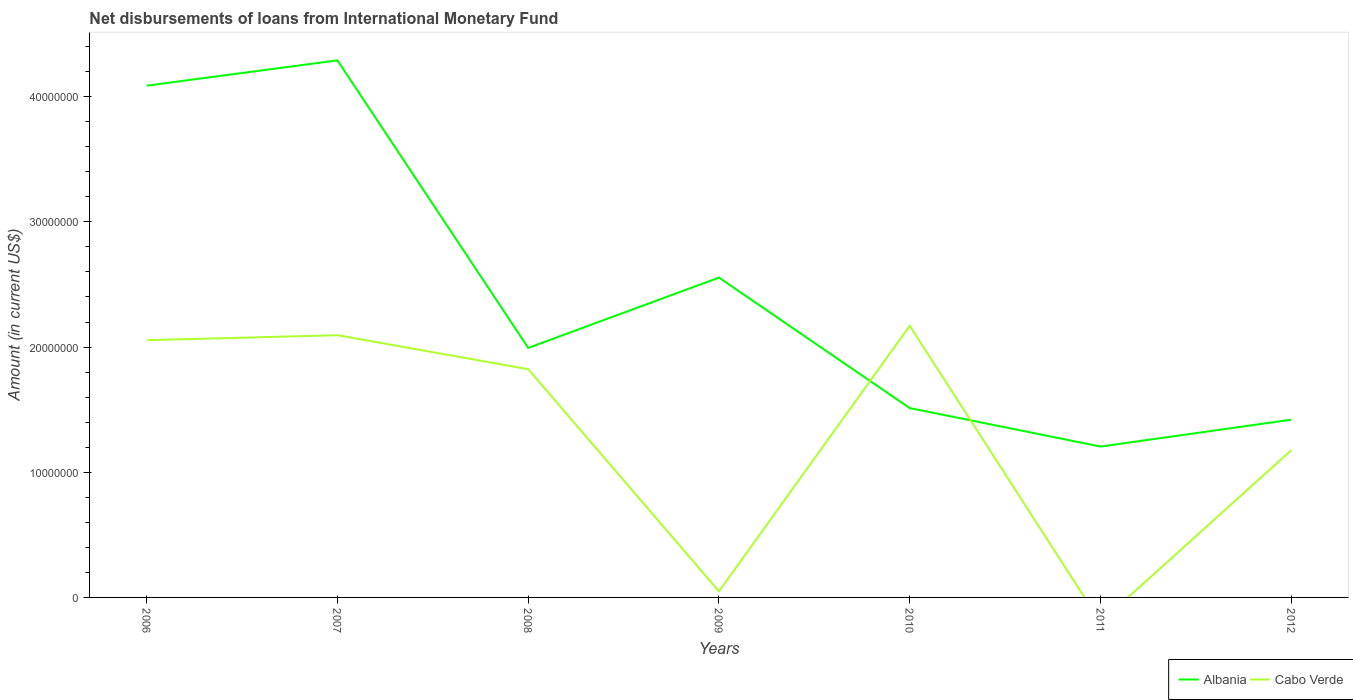How many different coloured lines are there?
Your answer should be very brief. 2. Is the number of lines equal to the number of legend labels?
Your answer should be very brief. No. Across all years, what is the maximum amount of loans disbursed in Albania?
Make the answer very short. 1.21e+07. What is the total amount of loans disbursed in Albania in the graph?
Your answer should be very brief. 1.35e+07. What is the difference between the highest and the second highest amount of loans disbursed in Albania?
Your answer should be very brief. 3.08e+07. What is the difference between the highest and the lowest amount of loans disbursed in Albania?
Your answer should be compact. 3. Is the amount of loans disbursed in Albania strictly greater than the amount of loans disbursed in Cabo Verde over the years?
Provide a succinct answer. No. Does the graph contain any zero values?
Your answer should be compact. Yes. How many legend labels are there?
Keep it short and to the point. 2. How are the legend labels stacked?
Provide a short and direct response. Horizontal. What is the title of the graph?
Provide a succinct answer. Net disbursements of loans from International Monetary Fund. What is the label or title of the X-axis?
Your response must be concise. Years. What is the label or title of the Y-axis?
Ensure brevity in your answer.  Amount (in current US$). What is the Amount (in current US$) in Albania in 2006?
Give a very brief answer. 4.09e+07. What is the Amount (in current US$) in Cabo Verde in 2006?
Give a very brief answer. 2.05e+07. What is the Amount (in current US$) in Albania in 2007?
Your answer should be compact. 4.29e+07. What is the Amount (in current US$) of Cabo Verde in 2007?
Your answer should be compact. 2.09e+07. What is the Amount (in current US$) in Albania in 2008?
Your response must be concise. 1.99e+07. What is the Amount (in current US$) of Cabo Verde in 2008?
Offer a terse response. 1.82e+07. What is the Amount (in current US$) in Albania in 2009?
Ensure brevity in your answer.  2.55e+07. What is the Amount (in current US$) in Cabo Verde in 2009?
Ensure brevity in your answer.  4.88e+05. What is the Amount (in current US$) in Albania in 2010?
Provide a short and direct response. 1.51e+07. What is the Amount (in current US$) of Cabo Verde in 2010?
Your answer should be very brief. 2.17e+07. What is the Amount (in current US$) of Albania in 2011?
Your answer should be compact. 1.21e+07. What is the Amount (in current US$) of Albania in 2012?
Provide a succinct answer. 1.42e+07. What is the Amount (in current US$) in Cabo Verde in 2012?
Provide a short and direct response. 1.18e+07. Across all years, what is the maximum Amount (in current US$) of Albania?
Provide a succinct answer. 4.29e+07. Across all years, what is the maximum Amount (in current US$) of Cabo Verde?
Offer a terse response. 2.17e+07. Across all years, what is the minimum Amount (in current US$) in Albania?
Keep it short and to the point. 1.21e+07. What is the total Amount (in current US$) in Albania in the graph?
Offer a terse response. 1.71e+08. What is the total Amount (in current US$) of Cabo Verde in the graph?
Keep it short and to the point. 9.37e+07. What is the difference between the Amount (in current US$) in Albania in 2006 and that in 2007?
Offer a terse response. -2.02e+06. What is the difference between the Amount (in current US$) of Cabo Verde in 2006 and that in 2007?
Make the answer very short. -3.97e+05. What is the difference between the Amount (in current US$) in Albania in 2006 and that in 2008?
Provide a succinct answer. 2.09e+07. What is the difference between the Amount (in current US$) in Cabo Verde in 2006 and that in 2008?
Provide a short and direct response. 2.32e+06. What is the difference between the Amount (in current US$) in Albania in 2006 and that in 2009?
Offer a very short reply. 1.53e+07. What is the difference between the Amount (in current US$) of Cabo Verde in 2006 and that in 2009?
Your answer should be very brief. 2.01e+07. What is the difference between the Amount (in current US$) in Albania in 2006 and that in 2010?
Offer a very short reply. 2.58e+07. What is the difference between the Amount (in current US$) of Cabo Verde in 2006 and that in 2010?
Your answer should be compact. -1.15e+06. What is the difference between the Amount (in current US$) in Albania in 2006 and that in 2011?
Your answer should be compact. 2.88e+07. What is the difference between the Amount (in current US$) in Albania in 2006 and that in 2012?
Offer a very short reply. 2.67e+07. What is the difference between the Amount (in current US$) of Cabo Verde in 2006 and that in 2012?
Make the answer very short. 8.79e+06. What is the difference between the Amount (in current US$) of Albania in 2007 and that in 2008?
Provide a succinct answer. 2.30e+07. What is the difference between the Amount (in current US$) in Cabo Verde in 2007 and that in 2008?
Provide a short and direct response. 2.72e+06. What is the difference between the Amount (in current US$) of Albania in 2007 and that in 2009?
Offer a very short reply. 1.74e+07. What is the difference between the Amount (in current US$) of Cabo Verde in 2007 and that in 2009?
Provide a succinct answer. 2.05e+07. What is the difference between the Amount (in current US$) of Albania in 2007 and that in 2010?
Your answer should be compact. 2.78e+07. What is the difference between the Amount (in current US$) of Cabo Verde in 2007 and that in 2010?
Your answer should be very brief. -7.52e+05. What is the difference between the Amount (in current US$) of Albania in 2007 and that in 2011?
Provide a short and direct response. 3.08e+07. What is the difference between the Amount (in current US$) in Albania in 2007 and that in 2012?
Your response must be concise. 2.87e+07. What is the difference between the Amount (in current US$) of Cabo Verde in 2007 and that in 2012?
Keep it short and to the point. 9.18e+06. What is the difference between the Amount (in current US$) in Albania in 2008 and that in 2009?
Provide a short and direct response. -5.62e+06. What is the difference between the Amount (in current US$) of Cabo Verde in 2008 and that in 2009?
Your answer should be very brief. 1.77e+07. What is the difference between the Amount (in current US$) of Albania in 2008 and that in 2010?
Give a very brief answer. 4.81e+06. What is the difference between the Amount (in current US$) of Cabo Verde in 2008 and that in 2010?
Your answer should be compact. -3.47e+06. What is the difference between the Amount (in current US$) of Albania in 2008 and that in 2011?
Provide a succinct answer. 7.88e+06. What is the difference between the Amount (in current US$) in Albania in 2008 and that in 2012?
Your answer should be very brief. 5.73e+06. What is the difference between the Amount (in current US$) of Cabo Verde in 2008 and that in 2012?
Provide a short and direct response. 6.47e+06. What is the difference between the Amount (in current US$) in Albania in 2009 and that in 2010?
Ensure brevity in your answer.  1.04e+07. What is the difference between the Amount (in current US$) of Cabo Verde in 2009 and that in 2010?
Make the answer very short. -2.12e+07. What is the difference between the Amount (in current US$) of Albania in 2009 and that in 2011?
Make the answer very short. 1.35e+07. What is the difference between the Amount (in current US$) in Albania in 2009 and that in 2012?
Your response must be concise. 1.14e+07. What is the difference between the Amount (in current US$) in Cabo Verde in 2009 and that in 2012?
Offer a terse response. -1.13e+07. What is the difference between the Amount (in current US$) in Albania in 2010 and that in 2011?
Ensure brevity in your answer.  3.07e+06. What is the difference between the Amount (in current US$) in Albania in 2010 and that in 2012?
Provide a succinct answer. 9.26e+05. What is the difference between the Amount (in current US$) of Cabo Verde in 2010 and that in 2012?
Provide a succinct answer. 9.94e+06. What is the difference between the Amount (in current US$) of Albania in 2011 and that in 2012?
Ensure brevity in your answer.  -2.15e+06. What is the difference between the Amount (in current US$) of Albania in 2006 and the Amount (in current US$) of Cabo Verde in 2007?
Provide a succinct answer. 1.99e+07. What is the difference between the Amount (in current US$) in Albania in 2006 and the Amount (in current US$) in Cabo Verde in 2008?
Offer a terse response. 2.26e+07. What is the difference between the Amount (in current US$) in Albania in 2006 and the Amount (in current US$) in Cabo Verde in 2009?
Ensure brevity in your answer.  4.04e+07. What is the difference between the Amount (in current US$) of Albania in 2006 and the Amount (in current US$) of Cabo Verde in 2010?
Ensure brevity in your answer.  1.92e+07. What is the difference between the Amount (in current US$) of Albania in 2006 and the Amount (in current US$) of Cabo Verde in 2012?
Provide a short and direct response. 2.91e+07. What is the difference between the Amount (in current US$) in Albania in 2007 and the Amount (in current US$) in Cabo Verde in 2008?
Your answer should be very brief. 2.47e+07. What is the difference between the Amount (in current US$) of Albania in 2007 and the Amount (in current US$) of Cabo Verde in 2009?
Provide a short and direct response. 4.24e+07. What is the difference between the Amount (in current US$) in Albania in 2007 and the Amount (in current US$) in Cabo Verde in 2010?
Your response must be concise. 2.12e+07. What is the difference between the Amount (in current US$) of Albania in 2007 and the Amount (in current US$) of Cabo Verde in 2012?
Your answer should be very brief. 3.11e+07. What is the difference between the Amount (in current US$) in Albania in 2008 and the Amount (in current US$) in Cabo Verde in 2009?
Your answer should be very brief. 1.94e+07. What is the difference between the Amount (in current US$) of Albania in 2008 and the Amount (in current US$) of Cabo Verde in 2010?
Offer a terse response. -1.77e+06. What is the difference between the Amount (in current US$) of Albania in 2008 and the Amount (in current US$) of Cabo Verde in 2012?
Give a very brief answer. 8.17e+06. What is the difference between the Amount (in current US$) of Albania in 2009 and the Amount (in current US$) of Cabo Verde in 2010?
Give a very brief answer. 3.85e+06. What is the difference between the Amount (in current US$) of Albania in 2009 and the Amount (in current US$) of Cabo Verde in 2012?
Give a very brief answer. 1.38e+07. What is the difference between the Amount (in current US$) in Albania in 2010 and the Amount (in current US$) in Cabo Verde in 2012?
Provide a succinct answer. 3.36e+06. What is the average Amount (in current US$) of Albania per year?
Ensure brevity in your answer.  2.44e+07. What is the average Amount (in current US$) of Cabo Verde per year?
Give a very brief answer. 1.34e+07. In the year 2006, what is the difference between the Amount (in current US$) of Albania and Amount (in current US$) of Cabo Verde?
Provide a short and direct response. 2.03e+07. In the year 2007, what is the difference between the Amount (in current US$) in Albania and Amount (in current US$) in Cabo Verde?
Offer a very short reply. 2.20e+07. In the year 2008, what is the difference between the Amount (in current US$) in Albania and Amount (in current US$) in Cabo Verde?
Your answer should be compact. 1.70e+06. In the year 2009, what is the difference between the Amount (in current US$) of Albania and Amount (in current US$) of Cabo Verde?
Provide a succinct answer. 2.51e+07. In the year 2010, what is the difference between the Amount (in current US$) of Albania and Amount (in current US$) of Cabo Verde?
Give a very brief answer. -6.57e+06. In the year 2012, what is the difference between the Amount (in current US$) in Albania and Amount (in current US$) in Cabo Verde?
Provide a short and direct response. 2.44e+06. What is the ratio of the Amount (in current US$) in Albania in 2006 to that in 2007?
Give a very brief answer. 0.95. What is the ratio of the Amount (in current US$) of Cabo Verde in 2006 to that in 2007?
Make the answer very short. 0.98. What is the ratio of the Amount (in current US$) in Albania in 2006 to that in 2008?
Offer a very short reply. 2.05. What is the ratio of the Amount (in current US$) in Cabo Verde in 2006 to that in 2008?
Your answer should be compact. 1.13. What is the ratio of the Amount (in current US$) in Albania in 2006 to that in 2009?
Your response must be concise. 1.6. What is the ratio of the Amount (in current US$) in Cabo Verde in 2006 to that in 2009?
Ensure brevity in your answer.  42.11. What is the ratio of the Amount (in current US$) of Albania in 2006 to that in 2010?
Your response must be concise. 2.7. What is the ratio of the Amount (in current US$) of Cabo Verde in 2006 to that in 2010?
Give a very brief answer. 0.95. What is the ratio of the Amount (in current US$) in Albania in 2006 to that in 2011?
Give a very brief answer. 3.39. What is the ratio of the Amount (in current US$) of Albania in 2006 to that in 2012?
Ensure brevity in your answer.  2.88. What is the ratio of the Amount (in current US$) in Cabo Verde in 2006 to that in 2012?
Your answer should be compact. 1.75. What is the ratio of the Amount (in current US$) in Albania in 2007 to that in 2008?
Provide a succinct answer. 2.15. What is the ratio of the Amount (in current US$) of Cabo Verde in 2007 to that in 2008?
Make the answer very short. 1.15. What is the ratio of the Amount (in current US$) in Albania in 2007 to that in 2009?
Offer a very short reply. 1.68. What is the ratio of the Amount (in current US$) in Cabo Verde in 2007 to that in 2009?
Your response must be concise. 42.92. What is the ratio of the Amount (in current US$) in Albania in 2007 to that in 2010?
Your response must be concise. 2.84. What is the ratio of the Amount (in current US$) in Cabo Verde in 2007 to that in 2010?
Your answer should be very brief. 0.97. What is the ratio of the Amount (in current US$) in Albania in 2007 to that in 2011?
Offer a terse response. 3.56. What is the ratio of the Amount (in current US$) in Albania in 2007 to that in 2012?
Your answer should be compact. 3.02. What is the ratio of the Amount (in current US$) of Cabo Verde in 2007 to that in 2012?
Give a very brief answer. 1.78. What is the ratio of the Amount (in current US$) in Albania in 2008 to that in 2009?
Provide a succinct answer. 0.78. What is the ratio of the Amount (in current US$) of Cabo Verde in 2008 to that in 2009?
Your response must be concise. 37.36. What is the ratio of the Amount (in current US$) of Albania in 2008 to that in 2010?
Your answer should be compact. 1.32. What is the ratio of the Amount (in current US$) of Cabo Verde in 2008 to that in 2010?
Offer a terse response. 0.84. What is the ratio of the Amount (in current US$) in Albania in 2008 to that in 2011?
Make the answer very short. 1.65. What is the ratio of the Amount (in current US$) in Albania in 2008 to that in 2012?
Provide a short and direct response. 1.4. What is the ratio of the Amount (in current US$) of Cabo Verde in 2008 to that in 2012?
Give a very brief answer. 1.55. What is the ratio of the Amount (in current US$) of Albania in 2009 to that in 2010?
Make the answer very short. 1.69. What is the ratio of the Amount (in current US$) in Cabo Verde in 2009 to that in 2010?
Your response must be concise. 0.02. What is the ratio of the Amount (in current US$) of Albania in 2009 to that in 2011?
Your answer should be very brief. 2.12. What is the ratio of the Amount (in current US$) in Albania in 2009 to that in 2012?
Ensure brevity in your answer.  1.8. What is the ratio of the Amount (in current US$) in Cabo Verde in 2009 to that in 2012?
Give a very brief answer. 0.04. What is the ratio of the Amount (in current US$) in Albania in 2010 to that in 2011?
Your response must be concise. 1.25. What is the ratio of the Amount (in current US$) in Albania in 2010 to that in 2012?
Your response must be concise. 1.07. What is the ratio of the Amount (in current US$) in Cabo Verde in 2010 to that in 2012?
Ensure brevity in your answer.  1.84. What is the ratio of the Amount (in current US$) of Albania in 2011 to that in 2012?
Give a very brief answer. 0.85. What is the difference between the highest and the second highest Amount (in current US$) in Albania?
Your answer should be compact. 2.02e+06. What is the difference between the highest and the second highest Amount (in current US$) of Cabo Verde?
Your answer should be compact. 7.52e+05. What is the difference between the highest and the lowest Amount (in current US$) of Albania?
Ensure brevity in your answer.  3.08e+07. What is the difference between the highest and the lowest Amount (in current US$) in Cabo Verde?
Make the answer very short. 2.17e+07. 